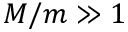<formula> <loc_0><loc_0><loc_500><loc_500>M / m \gg 1</formula> 